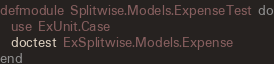<code> <loc_0><loc_0><loc_500><loc_500><_Elixir_>defmodule Splitwise.Models.ExpenseTest do
  use ExUnit.Case
  doctest ExSplitwise.Models.Expense
end
</code> 